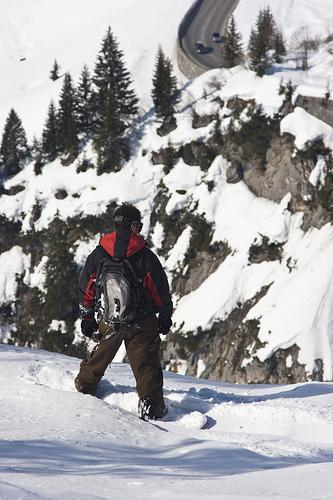What is near the trees? road 